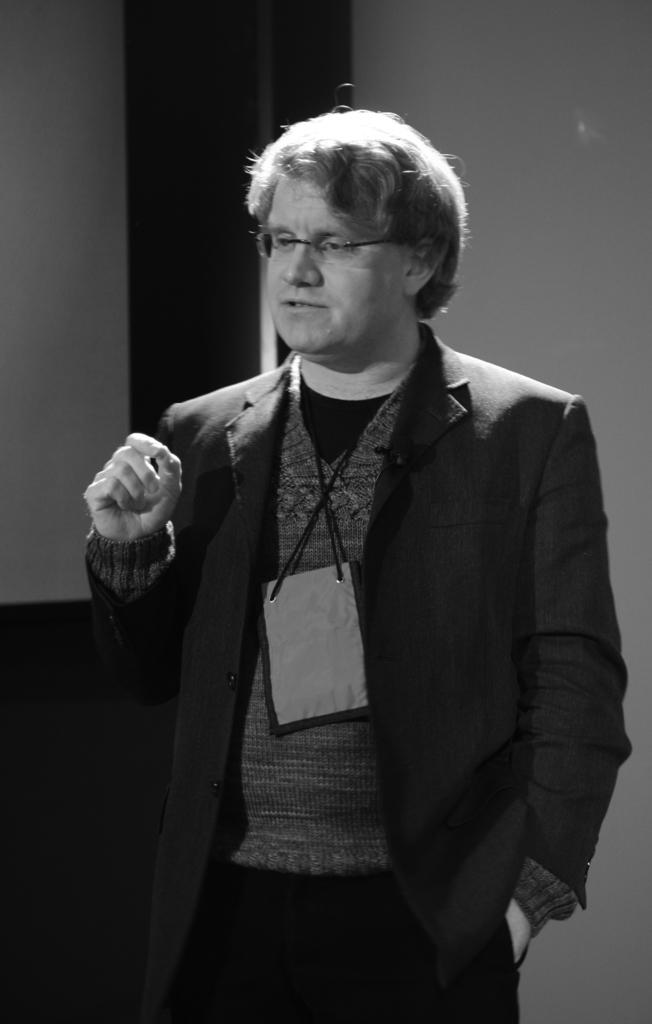What is the color scheme of the image? The image is black and white. What is the main subject in the image? There is a person standing in the center of the image. What is the person wearing? The person is wearing a different costume. What can be seen in the background of the image? There is a wall in the background of the image. What type of vase can be seen on the person's head in the image? There is no vase present on the person's head in the image. What book is the person holding in the image? There is no book visible in the image; the person is wearing a costume. 